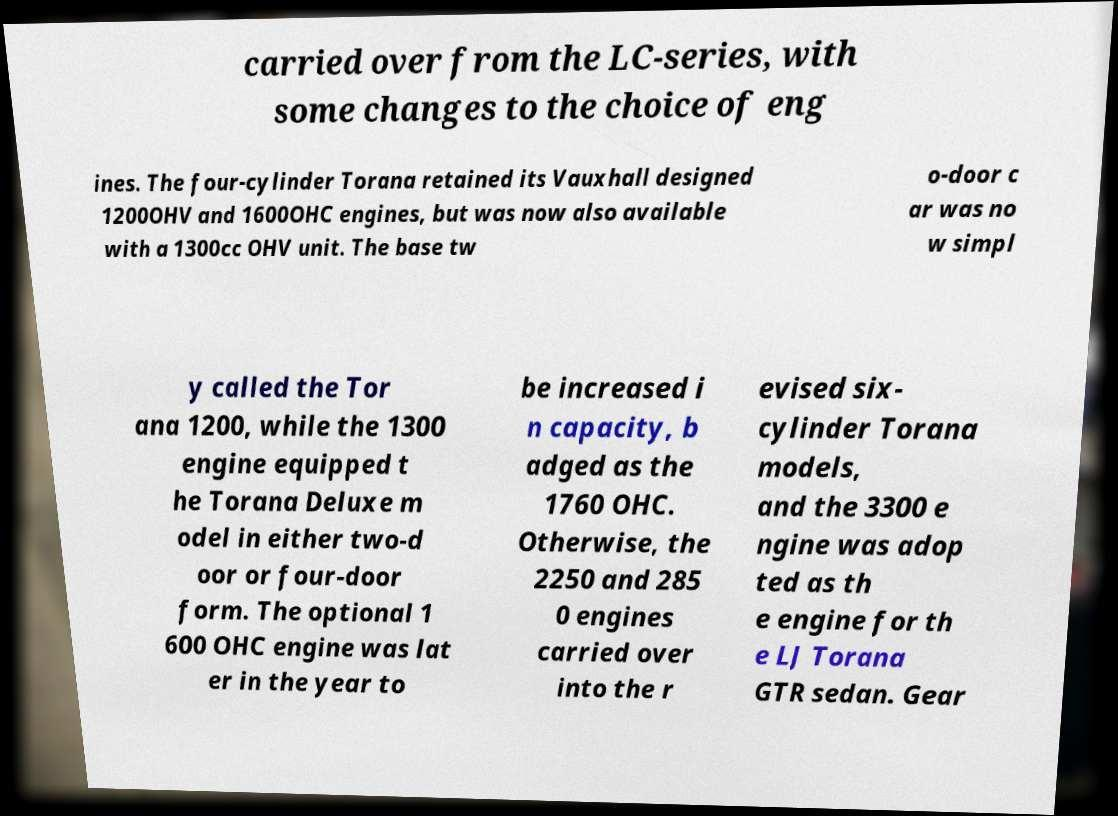For documentation purposes, I need the text within this image transcribed. Could you provide that? carried over from the LC-series, with some changes to the choice of eng ines. The four-cylinder Torana retained its Vauxhall designed 1200OHV and 1600OHC engines, but was now also available with a 1300cc OHV unit. The base tw o-door c ar was no w simpl y called the Tor ana 1200, while the 1300 engine equipped t he Torana Deluxe m odel in either two-d oor or four-door form. The optional 1 600 OHC engine was lat er in the year to be increased i n capacity, b adged as the 1760 OHC. Otherwise, the 2250 and 285 0 engines carried over into the r evised six- cylinder Torana models, and the 3300 e ngine was adop ted as th e engine for th e LJ Torana GTR sedan. Gear 